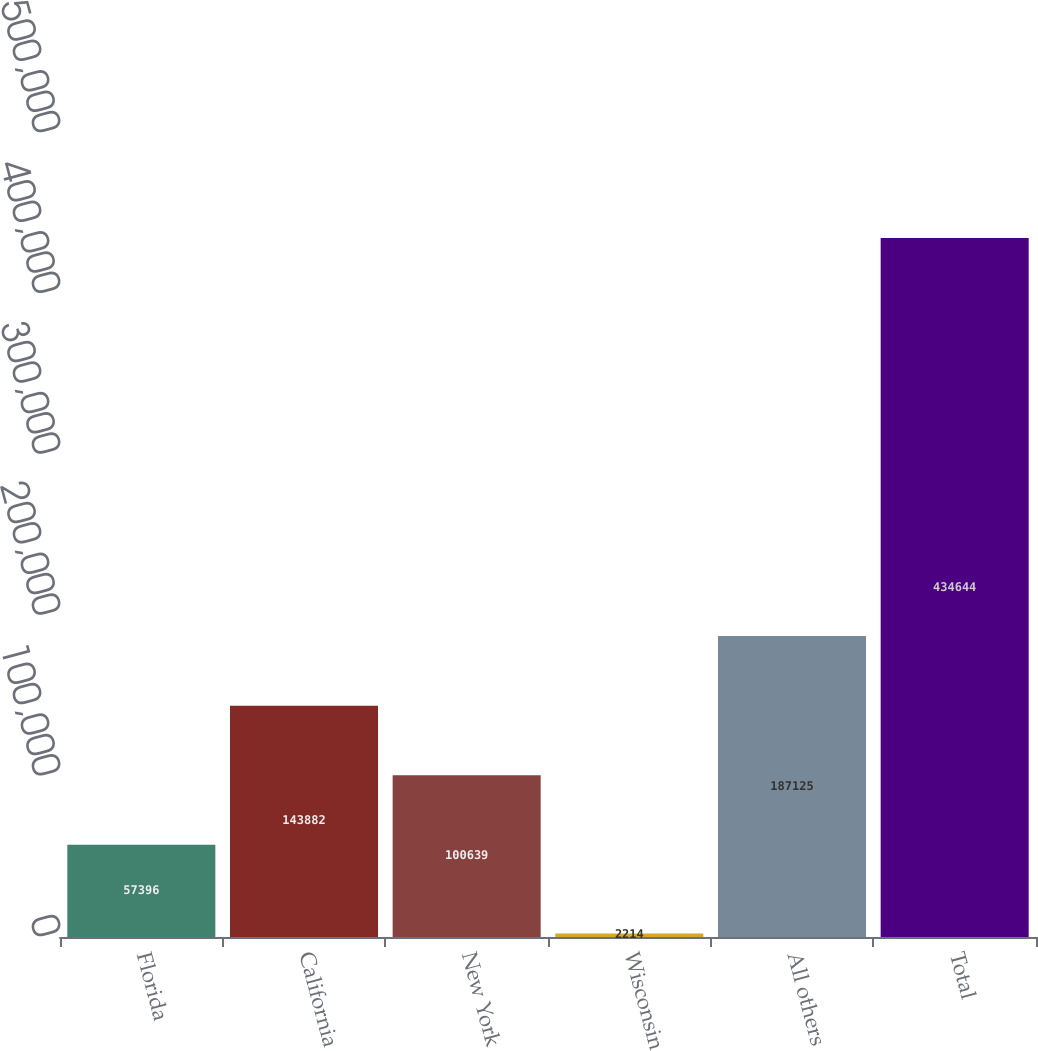<chart> <loc_0><loc_0><loc_500><loc_500><bar_chart><fcel>Florida<fcel>California<fcel>New York<fcel>Wisconsin<fcel>All others<fcel>Total<nl><fcel>57396<fcel>143882<fcel>100639<fcel>2214<fcel>187125<fcel>434644<nl></chart> 